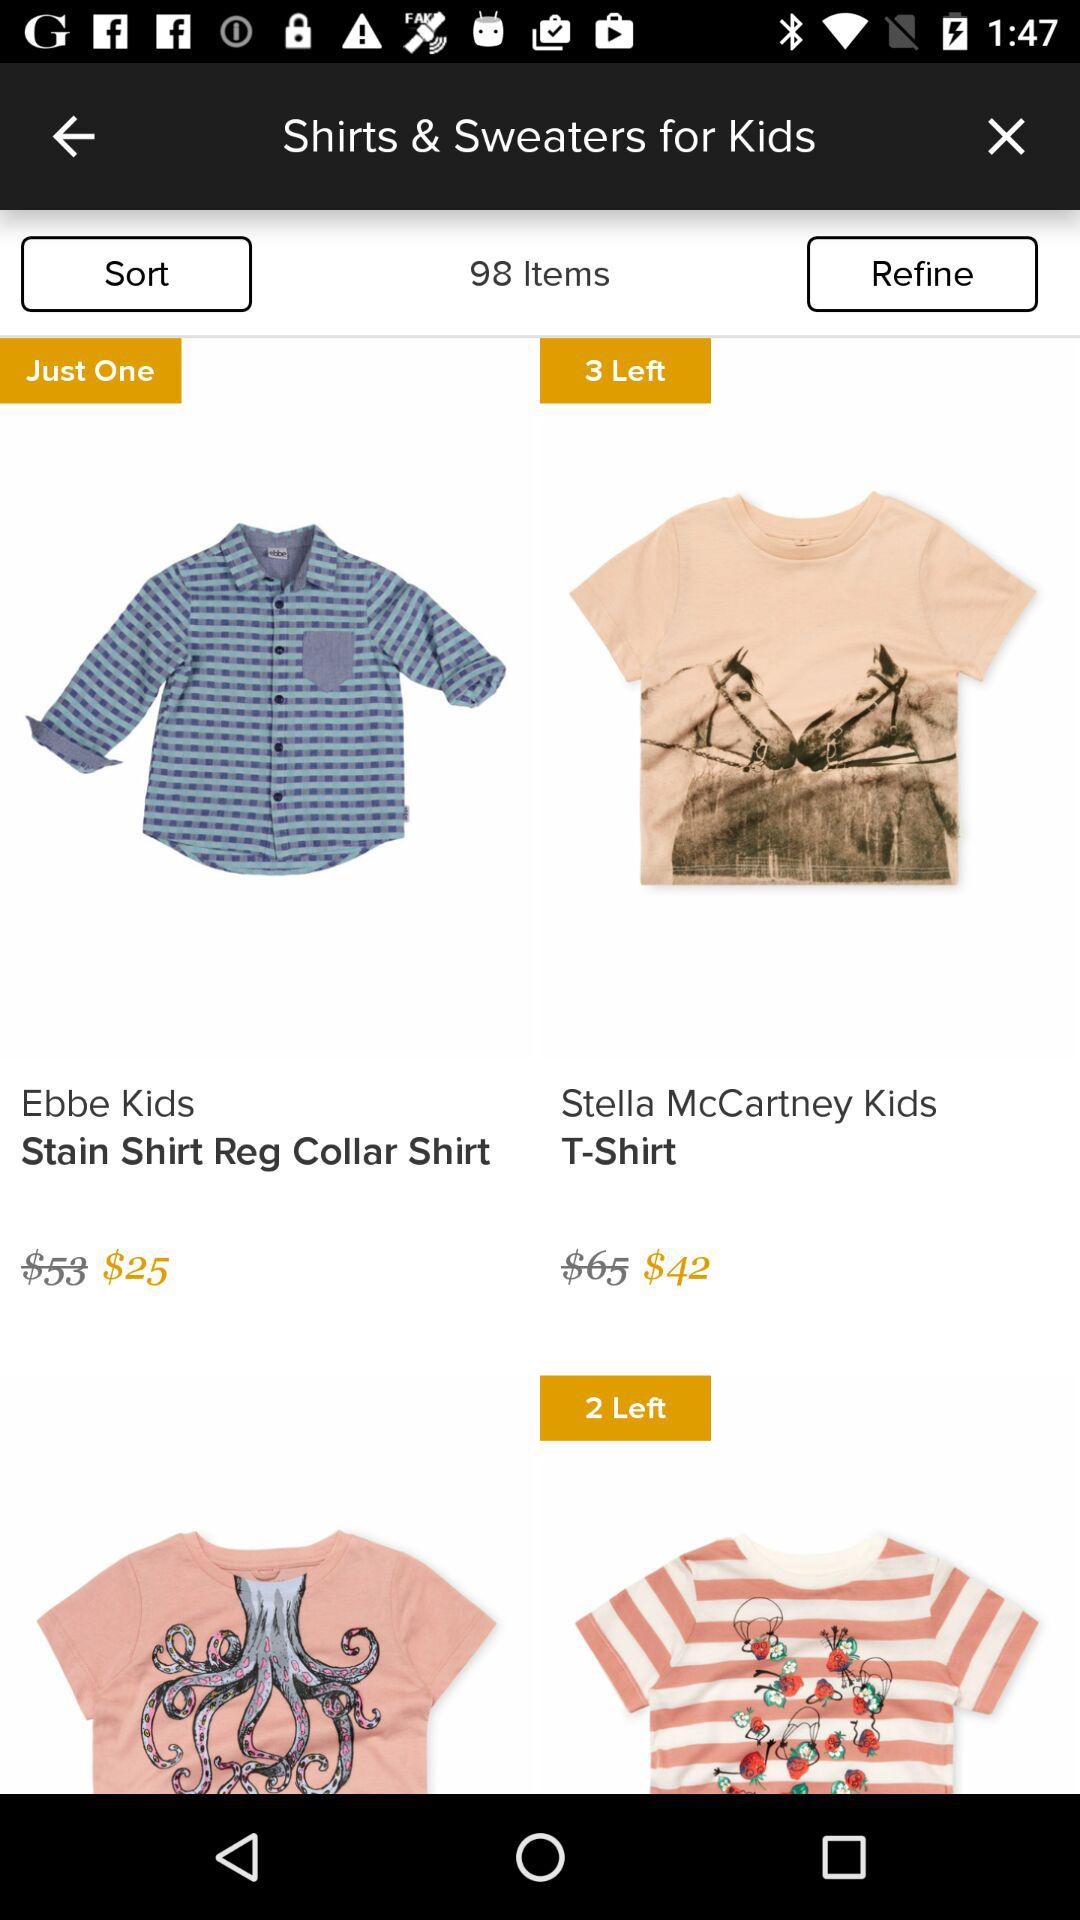How much does the Stella McCartney Kids T-shirt cost? The cost is $42. 